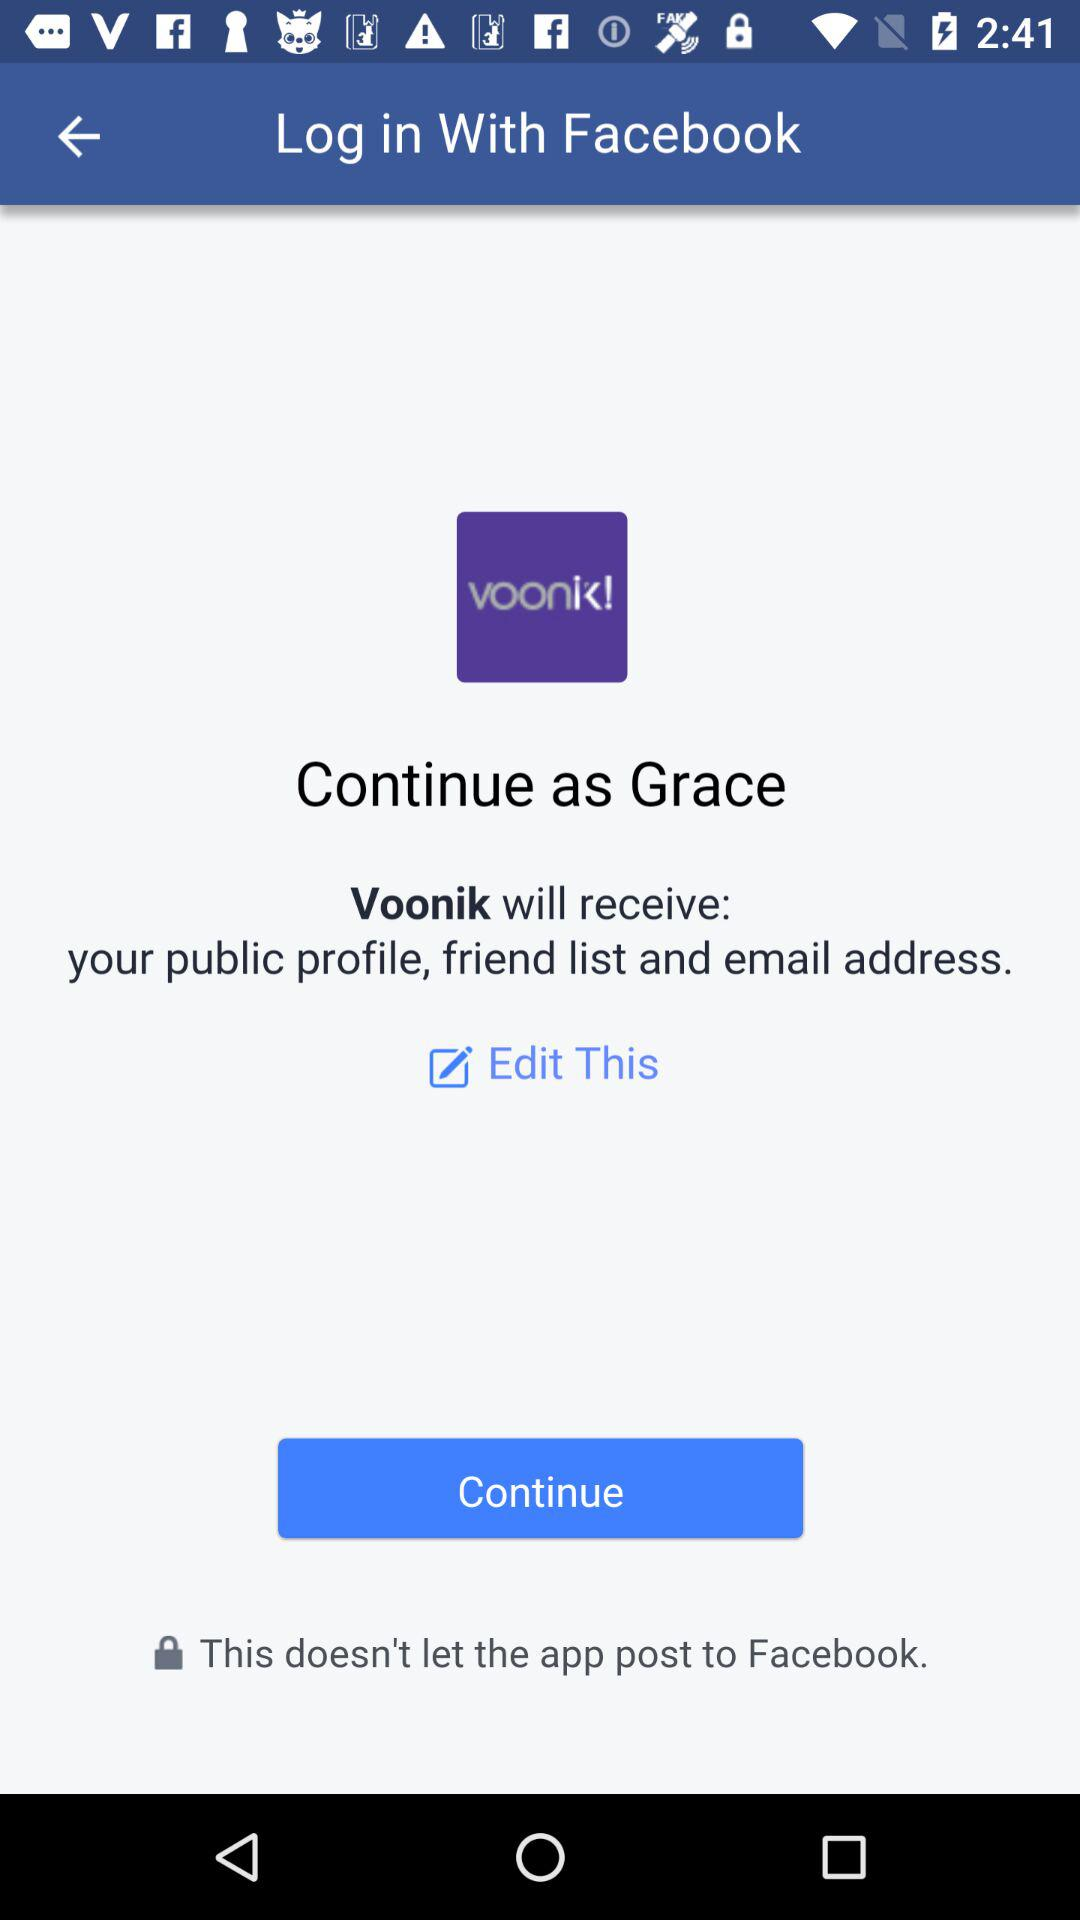How can we log in? You can log in with "Facebook". 